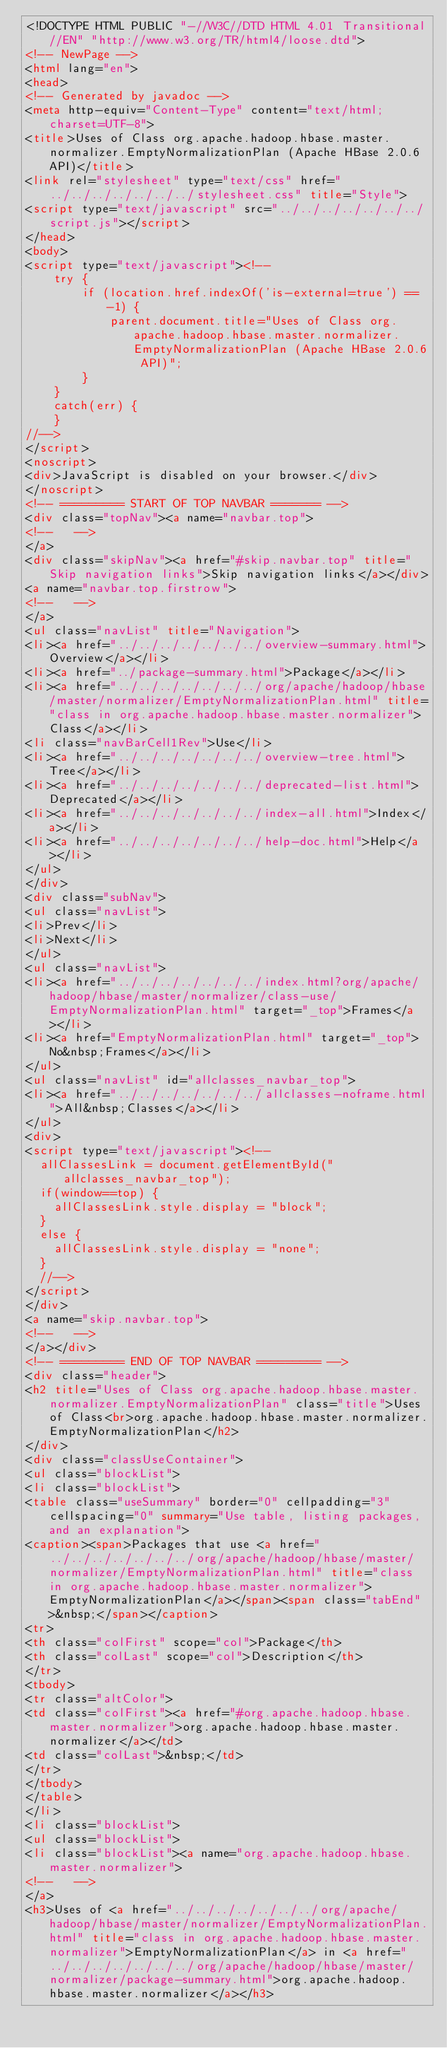Convert code to text. <code><loc_0><loc_0><loc_500><loc_500><_HTML_><!DOCTYPE HTML PUBLIC "-//W3C//DTD HTML 4.01 Transitional//EN" "http://www.w3.org/TR/html4/loose.dtd">
<!-- NewPage -->
<html lang="en">
<head>
<!-- Generated by javadoc -->
<meta http-equiv="Content-Type" content="text/html; charset=UTF-8">
<title>Uses of Class org.apache.hadoop.hbase.master.normalizer.EmptyNormalizationPlan (Apache HBase 2.0.6 API)</title>
<link rel="stylesheet" type="text/css" href="../../../../../../../stylesheet.css" title="Style">
<script type="text/javascript" src="../../../../../../../script.js"></script>
</head>
<body>
<script type="text/javascript"><!--
    try {
        if (location.href.indexOf('is-external=true') == -1) {
            parent.document.title="Uses of Class org.apache.hadoop.hbase.master.normalizer.EmptyNormalizationPlan (Apache HBase 2.0.6 API)";
        }
    }
    catch(err) {
    }
//-->
</script>
<noscript>
<div>JavaScript is disabled on your browser.</div>
</noscript>
<!-- ========= START OF TOP NAVBAR ======= -->
<div class="topNav"><a name="navbar.top">
<!--   -->
</a>
<div class="skipNav"><a href="#skip.navbar.top" title="Skip navigation links">Skip navigation links</a></div>
<a name="navbar.top.firstrow">
<!--   -->
</a>
<ul class="navList" title="Navigation">
<li><a href="../../../../../../../overview-summary.html">Overview</a></li>
<li><a href="../package-summary.html">Package</a></li>
<li><a href="../../../../../../../org/apache/hadoop/hbase/master/normalizer/EmptyNormalizationPlan.html" title="class in org.apache.hadoop.hbase.master.normalizer">Class</a></li>
<li class="navBarCell1Rev">Use</li>
<li><a href="../../../../../../../overview-tree.html">Tree</a></li>
<li><a href="../../../../../../../deprecated-list.html">Deprecated</a></li>
<li><a href="../../../../../../../index-all.html">Index</a></li>
<li><a href="../../../../../../../help-doc.html">Help</a></li>
</ul>
</div>
<div class="subNav">
<ul class="navList">
<li>Prev</li>
<li>Next</li>
</ul>
<ul class="navList">
<li><a href="../../../../../../../index.html?org/apache/hadoop/hbase/master/normalizer/class-use/EmptyNormalizationPlan.html" target="_top">Frames</a></li>
<li><a href="EmptyNormalizationPlan.html" target="_top">No&nbsp;Frames</a></li>
</ul>
<ul class="navList" id="allclasses_navbar_top">
<li><a href="../../../../../../../allclasses-noframe.html">All&nbsp;Classes</a></li>
</ul>
<div>
<script type="text/javascript"><!--
  allClassesLink = document.getElementById("allclasses_navbar_top");
  if(window==top) {
    allClassesLink.style.display = "block";
  }
  else {
    allClassesLink.style.display = "none";
  }
  //-->
</script>
</div>
<a name="skip.navbar.top">
<!--   -->
</a></div>
<!-- ========= END OF TOP NAVBAR ========= -->
<div class="header">
<h2 title="Uses of Class org.apache.hadoop.hbase.master.normalizer.EmptyNormalizationPlan" class="title">Uses of Class<br>org.apache.hadoop.hbase.master.normalizer.EmptyNormalizationPlan</h2>
</div>
<div class="classUseContainer">
<ul class="blockList">
<li class="blockList">
<table class="useSummary" border="0" cellpadding="3" cellspacing="0" summary="Use table, listing packages, and an explanation">
<caption><span>Packages that use <a href="../../../../../../../org/apache/hadoop/hbase/master/normalizer/EmptyNormalizationPlan.html" title="class in org.apache.hadoop.hbase.master.normalizer">EmptyNormalizationPlan</a></span><span class="tabEnd">&nbsp;</span></caption>
<tr>
<th class="colFirst" scope="col">Package</th>
<th class="colLast" scope="col">Description</th>
</tr>
<tbody>
<tr class="altColor">
<td class="colFirst"><a href="#org.apache.hadoop.hbase.master.normalizer">org.apache.hadoop.hbase.master.normalizer</a></td>
<td class="colLast">&nbsp;</td>
</tr>
</tbody>
</table>
</li>
<li class="blockList">
<ul class="blockList">
<li class="blockList"><a name="org.apache.hadoop.hbase.master.normalizer">
<!--   -->
</a>
<h3>Uses of <a href="../../../../../../../org/apache/hadoop/hbase/master/normalizer/EmptyNormalizationPlan.html" title="class in org.apache.hadoop.hbase.master.normalizer">EmptyNormalizationPlan</a> in <a href="../../../../../../../org/apache/hadoop/hbase/master/normalizer/package-summary.html">org.apache.hadoop.hbase.master.normalizer</a></h3></code> 